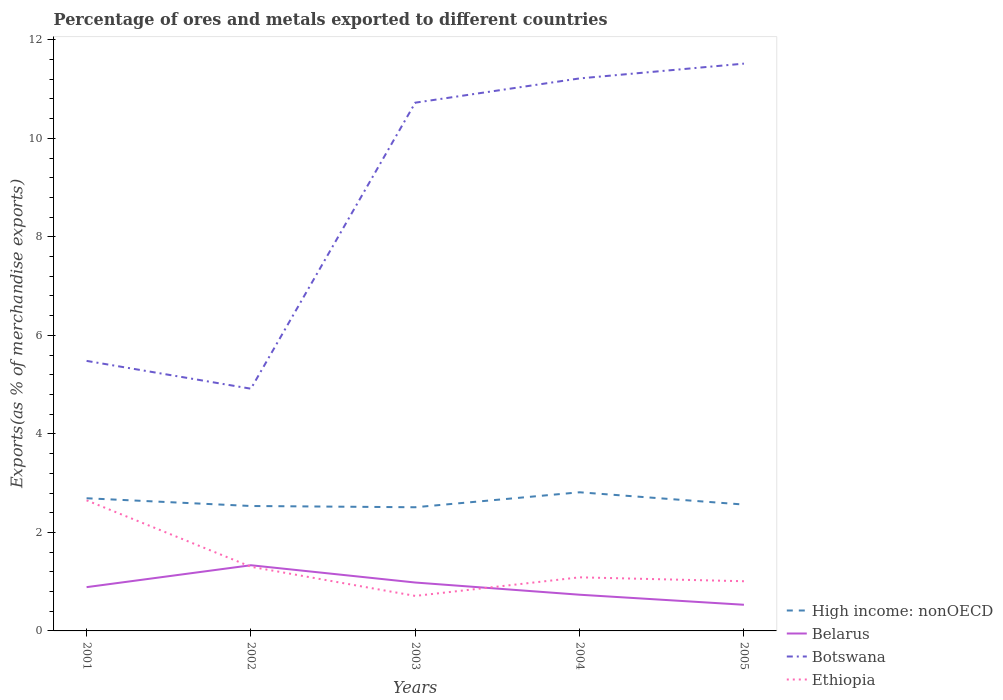Is the number of lines equal to the number of legend labels?
Keep it short and to the point. Yes. Across all years, what is the maximum percentage of exports to different countries in Botswana?
Make the answer very short. 4.92. What is the total percentage of exports to different countries in High income: nonOECD in the graph?
Provide a short and direct response. -0.12. What is the difference between the highest and the second highest percentage of exports to different countries in Botswana?
Your answer should be compact. 6.6. Is the percentage of exports to different countries in High income: nonOECD strictly greater than the percentage of exports to different countries in Ethiopia over the years?
Make the answer very short. No. How many years are there in the graph?
Your response must be concise. 5. What is the difference between two consecutive major ticks on the Y-axis?
Make the answer very short. 2. Are the values on the major ticks of Y-axis written in scientific E-notation?
Keep it short and to the point. No. What is the title of the graph?
Your answer should be very brief. Percentage of ores and metals exported to different countries. Does "Korea (Republic)" appear as one of the legend labels in the graph?
Offer a very short reply. No. What is the label or title of the X-axis?
Your response must be concise. Years. What is the label or title of the Y-axis?
Your answer should be very brief. Exports(as % of merchandise exports). What is the Exports(as % of merchandise exports) in High income: nonOECD in 2001?
Make the answer very short. 2.69. What is the Exports(as % of merchandise exports) in Belarus in 2001?
Make the answer very short. 0.89. What is the Exports(as % of merchandise exports) in Botswana in 2001?
Ensure brevity in your answer.  5.48. What is the Exports(as % of merchandise exports) of Ethiopia in 2001?
Keep it short and to the point. 2.65. What is the Exports(as % of merchandise exports) of High income: nonOECD in 2002?
Keep it short and to the point. 2.54. What is the Exports(as % of merchandise exports) in Belarus in 2002?
Offer a terse response. 1.33. What is the Exports(as % of merchandise exports) in Botswana in 2002?
Provide a succinct answer. 4.92. What is the Exports(as % of merchandise exports) of Ethiopia in 2002?
Make the answer very short. 1.3. What is the Exports(as % of merchandise exports) in High income: nonOECD in 2003?
Offer a very short reply. 2.51. What is the Exports(as % of merchandise exports) in Belarus in 2003?
Your answer should be very brief. 0.98. What is the Exports(as % of merchandise exports) of Botswana in 2003?
Keep it short and to the point. 10.72. What is the Exports(as % of merchandise exports) of Ethiopia in 2003?
Your answer should be very brief. 0.71. What is the Exports(as % of merchandise exports) in High income: nonOECD in 2004?
Your response must be concise. 2.81. What is the Exports(as % of merchandise exports) in Belarus in 2004?
Provide a short and direct response. 0.73. What is the Exports(as % of merchandise exports) of Botswana in 2004?
Offer a very short reply. 11.22. What is the Exports(as % of merchandise exports) in Ethiopia in 2004?
Give a very brief answer. 1.09. What is the Exports(as % of merchandise exports) of High income: nonOECD in 2005?
Your answer should be very brief. 2.57. What is the Exports(as % of merchandise exports) in Belarus in 2005?
Offer a very short reply. 0.53. What is the Exports(as % of merchandise exports) in Botswana in 2005?
Your answer should be compact. 11.52. What is the Exports(as % of merchandise exports) in Ethiopia in 2005?
Your response must be concise. 1.01. Across all years, what is the maximum Exports(as % of merchandise exports) of High income: nonOECD?
Offer a very short reply. 2.81. Across all years, what is the maximum Exports(as % of merchandise exports) in Belarus?
Your response must be concise. 1.33. Across all years, what is the maximum Exports(as % of merchandise exports) of Botswana?
Provide a short and direct response. 11.52. Across all years, what is the maximum Exports(as % of merchandise exports) in Ethiopia?
Provide a short and direct response. 2.65. Across all years, what is the minimum Exports(as % of merchandise exports) of High income: nonOECD?
Offer a terse response. 2.51. Across all years, what is the minimum Exports(as % of merchandise exports) of Belarus?
Make the answer very short. 0.53. Across all years, what is the minimum Exports(as % of merchandise exports) in Botswana?
Your response must be concise. 4.92. Across all years, what is the minimum Exports(as % of merchandise exports) of Ethiopia?
Keep it short and to the point. 0.71. What is the total Exports(as % of merchandise exports) of High income: nonOECD in the graph?
Keep it short and to the point. 13.12. What is the total Exports(as % of merchandise exports) of Belarus in the graph?
Keep it short and to the point. 4.47. What is the total Exports(as % of merchandise exports) in Botswana in the graph?
Give a very brief answer. 43.86. What is the total Exports(as % of merchandise exports) of Ethiopia in the graph?
Provide a short and direct response. 6.76. What is the difference between the Exports(as % of merchandise exports) of High income: nonOECD in 2001 and that in 2002?
Keep it short and to the point. 0.16. What is the difference between the Exports(as % of merchandise exports) of Belarus in 2001 and that in 2002?
Give a very brief answer. -0.44. What is the difference between the Exports(as % of merchandise exports) of Botswana in 2001 and that in 2002?
Your response must be concise. 0.56. What is the difference between the Exports(as % of merchandise exports) of Ethiopia in 2001 and that in 2002?
Give a very brief answer. 1.35. What is the difference between the Exports(as % of merchandise exports) in High income: nonOECD in 2001 and that in 2003?
Make the answer very short. 0.18. What is the difference between the Exports(as % of merchandise exports) of Belarus in 2001 and that in 2003?
Your answer should be compact. -0.09. What is the difference between the Exports(as % of merchandise exports) in Botswana in 2001 and that in 2003?
Provide a short and direct response. -5.24. What is the difference between the Exports(as % of merchandise exports) of Ethiopia in 2001 and that in 2003?
Offer a very short reply. 1.94. What is the difference between the Exports(as % of merchandise exports) in High income: nonOECD in 2001 and that in 2004?
Offer a very short reply. -0.12. What is the difference between the Exports(as % of merchandise exports) of Belarus in 2001 and that in 2004?
Make the answer very short. 0.15. What is the difference between the Exports(as % of merchandise exports) in Botswana in 2001 and that in 2004?
Your answer should be very brief. -5.74. What is the difference between the Exports(as % of merchandise exports) of Ethiopia in 2001 and that in 2004?
Offer a very short reply. 1.56. What is the difference between the Exports(as % of merchandise exports) in High income: nonOECD in 2001 and that in 2005?
Your answer should be compact. 0.13. What is the difference between the Exports(as % of merchandise exports) in Belarus in 2001 and that in 2005?
Ensure brevity in your answer.  0.36. What is the difference between the Exports(as % of merchandise exports) of Botswana in 2001 and that in 2005?
Provide a short and direct response. -6.04. What is the difference between the Exports(as % of merchandise exports) of Ethiopia in 2001 and that in 2005?
Keep it short and to the point. 1.64. What is the difference between the Exports(as % of merchandise exports) of High income: nonOECD in 2002 and that in 2003?
Make the answer very short. 0.03. What is the difference between the Exports(as % of merchandise exports) in Belarus in 2002 and that in 2003?
Keep it short and to the point. 0.35. What is the difference between the Exports(as % of merchandise exports) of Botswana in 2002 and that in 2003?
Give a very brief answer. -5.81. What is the difference between the Exports(as % of merchandise exports) of Ethiopia in 2002 and that in 2003?
Offer a terse response. 0.59. What is the difference between the Exports(as % of merchandise exports) in High income: nonOECD in 2002 and that in 2004?
Your answer should be compact. -0.28. What is the difference between the Exports(as % of merchandise exports) in Belarus in 2002 and that in 2004?
Give a very brief answer. 0.6. What is the difference between the Exports(as % of merchandise exports) of Botswana in 2002 and that in 2004?
Your answer should be very brief. -6.3. What is the difference between the Exports(as % of merchandise exports) in Ethiopia in 2002 and that in 2004?
Your answer should be compact. 0.21. What is the difference between the Exports(as % of merchandise exports) in High income: nonOECD in 2002 and that in 2005?
Keep it short and to the point. -0.03. What is the difference between the Exports(as % of merchandise exports) of Belarus in 2002 and that in 2005?
Keep it short and to the point. 0.8. What is the difference between the Exports(as % of merchandise exports) in Botswana in 2002 and that in 2005?
Give a very brief answer. -6.6. What is the difference between the Exports(as % of merchandise exports) in Ethiopia in 2002 and that in 2005?
Keep it short and to the point. 0.29. What is the difference between the Exports(as % of merchandise exports) in High income: nonOECD in 2003 and that in 2004?
Offer a very short reply. -0.3. What is the difference between the Exports(as % of merchandise exports) in Belarus in 2003 and that in 2004?
Keep it short and to the point. 0.25. What is the difference between the Exports(as % of merchandise exports) of Botswana in 2003 and that in 2004?
Your response must be concise. -0.49. What is the difference between the Exports(as % of merchandise exports) of Ethiopia in 2003 and that in 2004?
Offer a very short reply. -0.38. What is the difference between the Exports(as % of merchandise exports) in High income: nonOECD in 2003 and that in 2005?
Provide a succinct answer. -0.05. What is the difference between the Exports(as % of merchandise exports) in Belarus in 2003 and that in 2005?
Make the answer very short. 0.45. What is the difference between the Exports(as % of merchandise exports) of Botswana in 2003 and that in 2005?
Provide a succinct answer. -0.79. What is the difference between the Exports(as % of merchandise exports) of Ethiopia in 2003 and that in 2005?
Keep it short and to the point. -0.3. What is the difference between the Exports(as % of merchandise exports) of High income: nonOECD in 2004 and that in 2005?
Make the answer very short. 0.25. What is the difference between the Exports(as % of merchandise exports) in Belarus in 2004 and that in 2005?
Give a very brief answer. 0.2. What is the difference between the Exports(as % of merchandise exports) of Botswana in 2004 and that in 2005?
Your response must be concise. -0.3. What is the difference between the Exports(as % of merchandise exports) in Ethiopia in 2004 and that in 2005?
Make the answer very short. 0.08. What is the difference between the Exports(as % of merchandise exports) of High income: nonOECD in 2001 and the Exports(as % of merchandise exports) of Belarus in 2002?
Your answer should be very brief. 1.36. What is the difference between the Exports(as % of merchandise exports) of High income: nonOECD in 2001 and the Exports(as % of merchandise exports) of Botswana in 2002?
Keep it short and to the point. -2.22. What is the difference between the Exports(as % of merchandise exports) in High income: nonOECD in 2001 and the Exports(as % of merchandise exports) in Ethiopia in 2002?
Make the answer very short. 1.39. What is the difference between the Exports(as % of merchandise exports) in Belarus in 2001 and the Exports(as % of merchandise exports) in Botswana in 2002?
Your answer should be compact. -4.03. What is the difference between the Exports(as % of merchandise exports) of Belarus in 2001 and the Exports(as % of merchandise exports) of Ethiopia in 2002?
Provide a succinct answer. -0.41. What is the difference between the Exports(as % of merchandise exports) in Botswana in 2001 and the Exports(as % of merchandise exports) in Ethiopia in 2002?
Your answer should be very brief. 4.18. What is the difference between the Exports(as % of merchandise exports) of High income: nonOECD in 2001 and the Exports(as % of merchandise exports) of Belarus in 2003?
Make the answer very short. 1.71. What is the difference between the Exports(as % of merchandise exports) of High income: nonOECD in 2001 and the Exports(as % of merchandise exports) of Botswana in 2003?
Offer a very short reply. -8.03. What is the difference between the Exports(as % of merchandise exports) in High income: nonOECD in 2001 and the Exports(as % of merchandise exports) in Ethiopia in 2003?
Make the answer very short. 1.98. What is the difference between the Exports(as % of merchandise exports) of Belarus in 2001 and the Exports(as % of merchandise exports) of Botswana in 2003?
Make the answer very short. -9.84. What is the difference between the Exports(as % of merchandise exports) in Belarus in 2001 and the Exports(as % of merchandise exports) in Ethiopia in 2003?
Provide a short and direct response. 0.18. What is the difference between the Exports(as % of merchandise exports) in Botswana in 2001 and the Exports(as % of merchandise exports) in Ethiopia in 2003?
Offer a very short reply. 4.77. What is the difference between the Exports(as % of merchandise exports) in High income: nonOECD in 2001 and the Exports(as % of merchandise exports) in Belarus in 2004?
Give a very brief answer. 1.96. What is the difference between the Exports(as % of merchandise exports) in High income: nonOECD in 2001 and the Exports(as % of merchandise exports) in Botswana in 2004?
Give a very brief answer. -8.52. What is the difference between the Exports(as % of merchandise exports) in High income: nonOECD in 2001 and the Exports(as % of merchandise exports) in Ethiopia in 2004?
Give a very brief answer. 1.61. What is the difference between the Exports(as % of merchandise exports) of Belarus in 2001 and the Exports(as % of merchandise exports) of Botswana in 2004?
Make the answer very short. -10.33. What is the difference between the Exports(as % of merchandise exports) of Belarus in 2001 and the Exports(as % of merchandise exports) of Ethiopia in 2004?
Your response must be concise. -0.2. What is the difference between the Exports(as % of merchandise exports) of Botswana in 2001 and the Exports(as % of merchandise exports) of Ethiopia in 2004?
Provide a short and direct response. 4.39. What is the difference between the Exports(as % of merchandise exports) of High income: nonOECD in 2001 and the Exports(as % of merchandise exports) of Belarus in 2005?
Give a very brief answer. 2.16. What is the difference between the Exports(as % of merchandise exports) of High income: nonOECD in 2001 and the Exports(as % of merchandise exports) of Botswana in 2005?
Provide a succinct answer. -8.82. What is the difference between the Exports(as % of merchandise exports) in High income: nonOECD in 2001 and the Exports(as % of merchandise exports) in Ethiopia in 2005?
Your response must be concise. 1.68. What is the difference between the Exports(as % of merchandise exports) of Belarus in 2001 and the Exports(as % of merchandise exports) of Botswana in 2005?
Your answer should be compact. -10.63. What is the difference between the Exports(as % of merchandise exports) in Belarus in 2001 and the Exports(as % of merchandise exports) in Ethiopia in 2005?
Provide a short and direct response. -0.12. What is the difference between the Exports(as % of merchandise exports) of Botswana in 2001 and the Exports(as % of merchandise exports) of Ethiopia in 2005?
Give a very brief answer. 4.47. What is the difference between the Exports(as % of merchandise exports) in High income: nonOECD in 2002 and the Exports(as % of merchandise exports) in Belarus in 2003?
Keep it short and to the point. 1.55. What is the difference between the Exports(as % of merchandise exports) in High income: nonOECD in 2002 and the Exports(as % of merchandise exports) in Botswana in 2003?
Your answer should be compact. -8.19. What is the difference between the Exports(as % of merchandise exports) in High income: nonOECD in 2002 and the Exports(as % of merchandise exports) in Ethiopia in 2003?
Give a very brief answer. 1.83. What is the difference between the Exports(as % of merchandise exports) in Belarus in 2002 and the Exports(as % of merchandise exports) in Botswana in 2003?
Offer a very short reply. -9.39. What is the difference between the Exports(as % of merchandise exports) in Belarus in 2002 and the Exports(as % of merchandise exports) in Ethiopia in 2003?
Offer a terse response. 0.62. What is the difference between the Exports(as % of merchandise exports) in Botswana in 2002 and the Exports(as % of merchandise exports) in Ethiopia in 2003?
Provide a short and direct response. 4.21. What is the difference between the Exports(as % of merchandise exports) of High income: nonOECD in 2002 and the Exports(as % of merchandise exports) of Belarus in 2004?
Your answer should be compact. 1.8. What is the difference between the Exports(as % of merchandise exports) of High income: nonOECD in 2002 and the Exports(as % of merchandise exports) of Botswana in 2004?
Give a very brief answer. -8.68. What is the difference between the Exports(as % of merchandise exports) in High income: nonOECD in 2002 and the Exports(as % of merchandise exports) in Ethiopia in 2004?
Ensure brevity in your answer.  1.45. What is the difference between the Exports(as % of merchandise exports) in Belarus in 2002 and the Exports(as % of merchandise exports) in Botswana in 2004?
Your answer should be compact. -9.88. What is the difference between the Exports(as % of merchandise exports) of Belarus in 2002 and the Exports(as % of merchandise exports) of Ethiopia in 2004?
Your answer should be compact. 0.25. What is the difference between the Exports(as % of merchandise exports) in Botswana in 2002 and the Exports(as % of merchandise exports) in Ethiopia in 2004?
Make the answer very short. 3.83. What is the difference between the Exports(as % of merchandise exports) of High income: nonOECD in 2002 and the Exports(as % of merchandise exports) of Belarus in 2005?
Provide a short and direct response. 2.01. What is the difference between the Exports(as % of merchandise exports) in High income: nonOECD in 2002 and the Exports(as % of merchandise exports) in Botswana in 2005?
Keep it short and to the point. -8.98. What is the difference between the Exports(as % of merchandise exports) in High income: nonOECD in 2002 and the Exports(as % of merchandise exports) in Ethiopia in 2005?
Make the answer very short. 1.53. What is the difference between the Exports(as % of merchandise exports) in Belarus in 2002 and the Exports(as % of merchandise exports) in Botswana in 2005?
Your answer should be very brief. -10.18. What is the difference between the Exports(as % of merchandise exports) of Belarus in 2002 and the Exports(as % of merchandise exports) of Ethiopia in 2005?
Your answer should be compact. 0.32. What is the difference between the Exports(as % of merchandise exports) of Botswana in 2002 and the Exports(as % of merchandise exports) of Ethiopia in 2005?
Provide a succinct answer. 3.91. What is the difference between the Exports(as % of merchandise exports) in High income: nonOECD in 2003 and the Exports(as % of merchandise exports) in Belarus in 2004?
Give a very brief answer. 1.78. What is the difference between the Exports(as % of merchandise exports) in High income: nonOECD in 2003 and the Exports(as % of merchandise exports) in Botswana in 2004?
Offer a very short reply. -8.71. What is the difference between the Exports(as % of merchandise exports) of High income: nonOECD in 2003 and the Exports(as % of merchandise exports) of Ethiopia in 2004?
Keep it short and to the point. 1.42. What is the difference between the Exports(as % of merchandise exports) in Belarus in 2003 and the Exports(as % of merchandise exports) in Botswana in 2004?
Make the answer very short. -10.23. What is the difference between the Exports(as % of merchandise exports) in Belarus in 2003 and the Exports(as % of merchandise exports) in Ethiopia in 2004?
Your response must be concise. -0.11. What is the difference between the Exports(as % of merchandise exports) of Botswana in 2003 and the Exports(as % of merchandise exports) of Ethiopia in 2004?
Provide a short and direct response. 9.64. What is the difference between the Exports(as % of merchandise exports) of High income: nonOECD in 2003 and the Exports(as % of merchandise exports) of Belarus in 2005?
Offer a terse response. 1.98. What is the difference between the Exports(as % of merchandise exports) in High income: nonOECD in 2003 and the Exports(as % of merchandise exports) in Botswana in 2005?
Provide a succinct answer. -9.01. What is the difference between the Exports(as % of merchandise exports) in High income: nonOECD in 2003 and the Exports(as % of merchandise exports) in Ethiopia in 2005?
Give a very brief answer. 1.5. What is the difference between the Exports(as % of merchandise exports) of Belarus in 2003 and the Exports(as % of merchandise exports) of Botswana in 2005?
Make the answer very short. -10.53. What is the difference between the Exports(as % of merchandise exports) of Belarus in 2003 and the Exports(as % of merchandise exports) of Ethiopia in 2005?
Your response must be concise. -0.03. What is the difference between the Exports(as % of merchandise exports) in Botswana in 2003 and the Exports(as % of merchandise exports) in Ethiopia in 2005?
Provide a short and direct response. 9.72. What is the difference between the Exports(as % of merchandise exports) of High income: nonOECD in 2004 and the Exports(as % of merchandise exports) of Belarus in 2005?
Give a very brief answer. 2.28. What is the difference between the Exports(as % of merchandise exports) of High income: nonOECD in 2004 and the Exports(as % of merchandise exports) of Botswana in 2005?
Your answer should be compact. -8.7. What is the difference between the Exports(as % of merchandise exports) of High income: nonOECD in 2004 and the Exports(as % of merchandise exports) of Ethiopia in 2005?
Provide a short and direct response. 1.81. What is the difference between the Exports(as % of merchandise exports) of Belarus in 2004 and the Exports(as % of merchandise exports) of Botswana in 2005?
Give a very brief answer. -10.78. What is the difference between the Exports(as % of merchandise exports) of Belarus in 2004 and the Exports(as % of merchandise exports) of Ethiopia in 2005?
Offer a terse response. -0.27. What is the difference between the Exports(as % of merchandise exports) of Botswana in 2004 and the Exports(as % of merchandise exports) of Ethiopia in 2005?
Give a very brief answer. 10.21. What is the average Exports(as % of merchandise exports) in High income: nonOECD per year?
Make the answer very short. 2.62. What is the average Exports(as % of merchandise exports) in Belarus per year?
Keep it short and to the point. 0.89. What is the average Exports(as % of merchandise exports) in Botswana per year?
Provide a succinct answer. 8.77. What is the average Exports(as % of merchandise exports) in Ethiopia per year?
Ensure brevity in your answer.  1.35. In the year 2001, what is the difference between the Exports(as % of merchandise exports) in High income: nonOECD and Exports(as % of merchandise exports) in Belarus?
Give a very brief answer. 1.8. In the year 2001, what is the difference between the Exports(as % of merchandise exports) of High income: nonOECD and Exports(as % of merchandise exports) of Botswana?
Provide a short and direct response. -2.79. In the year 2001, what is the difference between the Exports(as % of merchandise exports) of High income: nonOECD and Exports(as % of merchandise exports) of Ethiopia?
Make the answer very short. 0.04. In the year 2001, what is the difference between the Exports(as % of merchandise exports) in Belarus and Exports(as % of merchandise exports) in Botswana?
Provide a short and direct response. -4.59. In the year 2001, what is the difference between the Exports(as % of merchandise exports) of Belarus and Exports(as % of merchandise exports) of Ethiopia?
Ensure brevity in your answer.  -1.76. In the year 2001, what is the difference between the Exports(as % of merchandise exports) of Botswana and Exports(as % of merchandise exports) of Ethiopia?
Offer a terse response. 2.83. In the year 2002, what is the difference between the Exports(as % of merchandise exports) of High income: nonOECD and Exports(as % of merchandise exports) of Belarus?
Your response must be concise. 1.2. In the year 2002, what is the difference between the Exports(as % of merchandise exports) of High income: nonOECD and Exports(as % of merchandise exports) of Botswana?
Offer a terse response. -2.38. In the year 2002, what is the difference between the Exports(as % of merchandise exports) in High income: nonOECD and Exports(as % of merchandise exports) in Ethiopia?
Offer a very short reply. 1.23. In the year 2002, what is the difference between the Exports(as % of merchandise exports) of Belarus and Exports(as % of merchandise exports) of Botswana?
Keep it short and to the point. -3.58. In the year 2002, what is the difference between the Exports(as % of merchandise exports) in Belarus and Exports(as % of merchandise exports) in Ethiopia?
Provide a succinct answer. 0.03. In the year 2002, what is the difference between the Exports(as % of merchandise exports) of Botswana and Exports(as % of merchandise exports) of Ethiopia?
Offer a terse response. 3.61. In the year 2003, what is the difference between the Exports(as % of merchandise exports) of High income: nonOECD and Exports(as % of merchandise exports) of Belarus?
Ensure brevity in your answer.  1.53. In the year 2003, what is the difference between the Exports(as % of merchandise exports) in High income: nonOECD and Exports(as % of merchandise exports) in Botswana?
Your response must be concise. -8.21. In the year 2003, what is the difference between the Exports(as % of merchandise exports) of High income: nonOECD and Exports(as % of merchandise exports) of Ethiopia?
Offer a terse response. 1.8. In the year 2003, what is the difference between the Exports(as % of merchandise exports) of Belarus and Exports(as % of merchandise exports) of Botswana?
Your answer should be compact. -9.74. In the year 2003, what is the difference between the Exports(as % of merchandise exports) of Belarus and Exports(as % of merchandise exports) of Ethiopia?
Offer a very short reply. 0.27. In the year 2003, what is the difference between the Exports(as % of merchandise exports) of Botswana and Exports(as % of merchandise exports) of Ethiopia?
Keep it short and to the point. 10.01. In the year 2004, what is the difference between the Exports(as % of merchandise exports) in High income: nonOECD and Exports(as % of merchandise exports) in Belarus?
Your answer should be compact. 2.08. In the year 2004, what is the difference between the Exports(as % of merchandise exports) in High income: nonOECD and Exports(as % of merchandise exports) in Botswana?
Give a very brief answer. -8.4. In the year 2004, what is the difference between the Exports(as % of merchandise exports) of High income: nonOECD and Exports(as % of merchandise exports) of Ethiopia?
Give a very brief answer. 1.73. In the year 2004, what is the difference between the Exports(as % of merchandise exports) in Belarus and Exports(as % of merchandise exports) in Botswana?
Your response must be concise. -10.48. In the year 2004, what is the difference between the Exports(as % of merchandise exports) in Belarus and Exports(as % of merchandise exports) in Ethiopia?
Make the answer very short. -0.35. In the year 2004, what is the difference between the Exports(as % of merchandise exports) of Botswana and Exports(as % of merchandise exports) of Ethiopia?
Offer a very short reply. 10.13. In the year 2005, what is the difference between the Exports(as % of merchandise exports) of High income: nonOECD and Exports(as % of merchandise exports) of Belarus?
Ensure brevity in your answer.  2.03. In the year 2005, what is the difference between the Exports(as % of merchandise exports) in High income: nonOECD and Exports(as % of merchandise exports) in Botswana?
Give a very brief answer. -8.95. In the year 2005, what is the difference between the Exports(as % of merchandise exports) of High income: nonOECD and Exports(as % of merchandise exports) of Ethiopia?
Offer a terse response. 1.56. In the year 2005, what is the difference between the Exports(as % of merchandise exports) of Belarus and Exports(as % of merchandise exports) of Botswana?
Offer a terse response. -10.99. In the year 2005, what is the difference between the Exports(as % of merchandise exports) of Belarus and Exports(as % of merchandise exports) of Ethiopia?
Ensure brevity in your answer.  -0.48. In the year 2005, what is the difference between the Exports(as % of merchandise exports) in Botswana and Exports(as % of merchandise exports) in Ethiopia?
Provide a succinct answer. 10.51. What is the ratio of the Exports(as % of merchandise exports) in High income: nonOECD in 2001 to that in 2002?
Offer a terse response. 1.06. What is the ratio of the Exports(as % of merchandise exports) in Belarus in 2001 to that in 2002?
Make the answer very short. 0.67. What is the ratio of the Exports(as % of merchandise exports) in Botswana in 2001 to that in 2002?
Provide a succinct answer. 1.11. What is the ratio of the Exports(as % of merchandise exports) in Ethiopia in 2001 to that in 2002?
Offer a very short reply. 2.04. What is the ratio of the Exports(as % of merchandise exports) of High income: nonOECD in 2001 to that in 2003?
Your response must be concise. 1.07. What is the ratio of the Exports(as % of merchandise exports) of Belarus in 2001 to that in 2003?
Your answer should be compact. 0.9. What is the ratio of the Exports(as % of merchandise exports) of Botswana in 2001 to that in 2003?
Ensure brevity in your answer.  0.51. What is the ratio of the Exports(as % of merchandise exports) of Ethiopia in 2001 to that in 2003?
Your response must be concise. 3.73. What is the ratio of the Exports(as % of merchandise exports) of High income: nonOECD in 2001 to that in 2004?
Ensure brevity in your answer.  0.96. What is the ratio of the Exports(as % of merchandise exports) of Belarus in 2001 to that in 2004?
Provide a short and direct response. 1.21. What is the ratio of the Exports(as % of merchandise exports) in Botswana in 2001 to that in 2004?
Your answer should be very brief. 0.49. What is the ratio of the Exports(as % of merchandise exports) in Ethiopia in 2001 to that in 2004?
Ensure brevity in your answer.  2.44. What is the ratio of the Exports(as % of merchandise exports) in High income: nonOECD in 2001 to that in 2005?
Your answer should be compact. 1.05. What is the ratio of the Exports(as % of merchandise exports) of Belarus in 2001 to that in 2005?
Keep it short and to the point. 1.67. What is the ratio of the Exports(as % of merchandise exports) of Botswana in 2001 to that in 2005?
Provide a succinct answer. 0.48. What is the ratio of the Exports(as % of merchandise exports) of Ethiopia in 2001 to that in 2005?
Ensure brevity in your answer.  2.63. What is the ratio of the Exports(as % of merchandise exports) in High income: nonOECD in 2002 to that in 2003?
Offer a very short reply. 1.01. What is the ratio of the Exports(as % of merchandise exports) of Belarus in 2002 to that in 2003?
Make the answer very short. 1.36. What is the ratio of the Exports(as % of merchandise exports) in Botswana in 2002 to that in 2003?
Offer a terse response. 0.46. What is the ratio of the Exports(as % of merchandise exports) in Ethiopia in 2002 to that in 2003?
Keep it short and to the point. 1.83. What is the ratio of the Exports(as % of merchandise exports) of High income: nonOECD in 2002 to that in 2004?
Give a very brief answer. 0.9. What is the ratio of the Exports(as % of merchandise exports) in Belarus in 2002 to that in 2004?
Your answer should be compact. 1.81. What is the ratio of the Exports(as % of merchandise exports) in Botswana in 2002 to that in 2004?
Offer a very short reply. 0.44. What is the ratio of the Exports(as % of merchandise exports) in Ethiopia in 2002 to that in 2004?
Provide a short and direct response. 1.2. What is the ratio of the Exports(as % of merchandise exports) of High income: nonOECD in 2002 to that in 2005?
Keep it short and to the point. 0.99. What is the ratio of the Exports(as % of merchandise exports) of Belarus in 2002 to that in 2005?
Make the answer very short. 2.51. What is the ratio of the Exports(as % of merchandise exports) in Botswana in 2002 to that in 2005?
Your answer should be compact. 0.43. What is the ratio of the Exports(as % of merchandise exports) of Ethiopia in 2002 to that in 2005?
Give a very brief answer. 1.29. What is the ratio of the Exports(as % of merchandise exports) of High income: nonOECD in 2003 to that in 2004?
Offer a very short reply. 0.89. What is the ratio of the Exports(as % of merchandise exports) of Belarus in 2003 to that in 2004?
Provide a short and direct response. 1.34. What is the ratio of the Exports(as % of merchandise exports) in Botswana in 2003 to that in 2004?
Offer a terse response. 0.96. What is the ratio of the Exports(as % of merchandise exports) in Ethiopia in 2003 to that in 2004?
Make the answer very short. 0.65. What is the ratio of the Exports(as % of merchandise exports) of High income: nonOECD in 2003 to that in 2005?
Offer a terse response. 0.98. What is the ratio of the Exports(as % of merchandise exports) in Belarus in 2003 to that in 2005?
Provide a short and direct response. 1.85. What is the ratio of the Exports(as % of merchandise exports) in Botswana in 2003 to that in 2005?
Provide a succinct answer. 0.93. What is the ratio of the Exports(as % of merchandise exports) of Ethiopia in 2003 to that in 2005?
Ensure brevity in your answer.  0.7. What is the ratio of the Exports(as % of merchandise exports) in High income: nonOECD in 2004 to that in 2005?
Offer a terse response. 1.1. What is the ratio of the Exports(as % of merchandise exports) of Belarus in 2004 to that in 2005?
Give a very brief answer. 1.38. What is the ratio of the Exports(as % of merchandise exports) of Botswana in 2004 to that in 2005?
Offer a terse response. 0.97. What is the ratio of the Exports(as % of merchandise exports) of Ethiopia in 2004 to that in 2005?
Offer a very short reply. 1.08. What is the difference between the highest and the second highest Exports(as % of merchandise exports) of High income: nonOECD?
Give a very brief answer. 0.12. What is the difference between the highest and the second highest Exports(as % of merchandise exports) in Belarus?
Your response must be concise. 0.35. What is the difference between the highest and the second highest Exports(as % of merchandise exports) of Botswana?
Keep it short and to the point. 0.3. What is the difference between the highest and the second highest Exports(as % of merchandise exports) of Ethiopia?
Make the answer very short. 1.35. What is the difference between the highest and the lowest Exports(as % of merchandise exports) of High income: nonOECD?
Offer a terse response. 0.3. What is the difference between the highest and the lowest Exports(as % of merchandise exports) in Belarus?
Provide a succinct answer. 0.8. What is the difference between the highest and the lowest Exports(as % of merchandise exports) in Botswana?
Offer a terse response. 6.6. What is the difference between the highest and the lowest Exports(as % of merchandise exports) in Ethiopia?
Give a very brief answer. 1.94. 